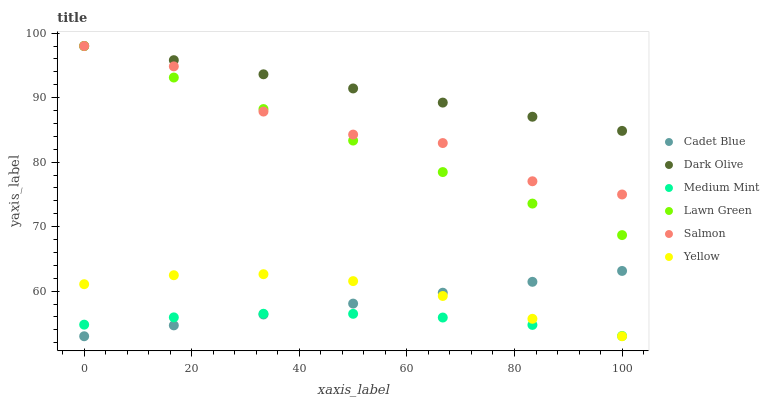Does Medium Mint have the minimum area under the curve?
Answer yes or no. Yes. Does Dark Olive have the maximum area under the curve?
Answer yes or no. Yes. Does Lawn Green have the minimum area under the curve?
Answer yes or no. No. Does Lawn Green have the maximum area under the curve?
Answer yes or no. No. Is Cadet Blue the smoothest?
Answer yes or no. Yes. Is Salmon the roughest?
Answer yes or no. Yes. Is Lawn Green the smoothest?
Answer yes or no. No. Is Lawn Green the roughest?
Answer yes or no. No. Does Cadet Blue have the lowest value?
Answer yes or no. Yes. Does Lawn Green have the lowest value?
Answer yes or no. No. Does Salmon have the highest value?
Answer yes or no. Yes. Does Cadet Blue have the highest value?
Answer yes or no. No. Is Yellow less than Lawn Green?
Answer yes or no. Yes. Is Lawn Green greater than Yellow?
Answer yes or no. Yes. Does Salmon intersect Lawn Green?
Answer yes or no. Yes. Is Salmon less than Lawn Green?
Answer yes or no. No. Is Salmon greater than Lawn Green?
Answer yes or no. No. Does Yellow intersect Lawn Green?
Answer yes or no. No. 